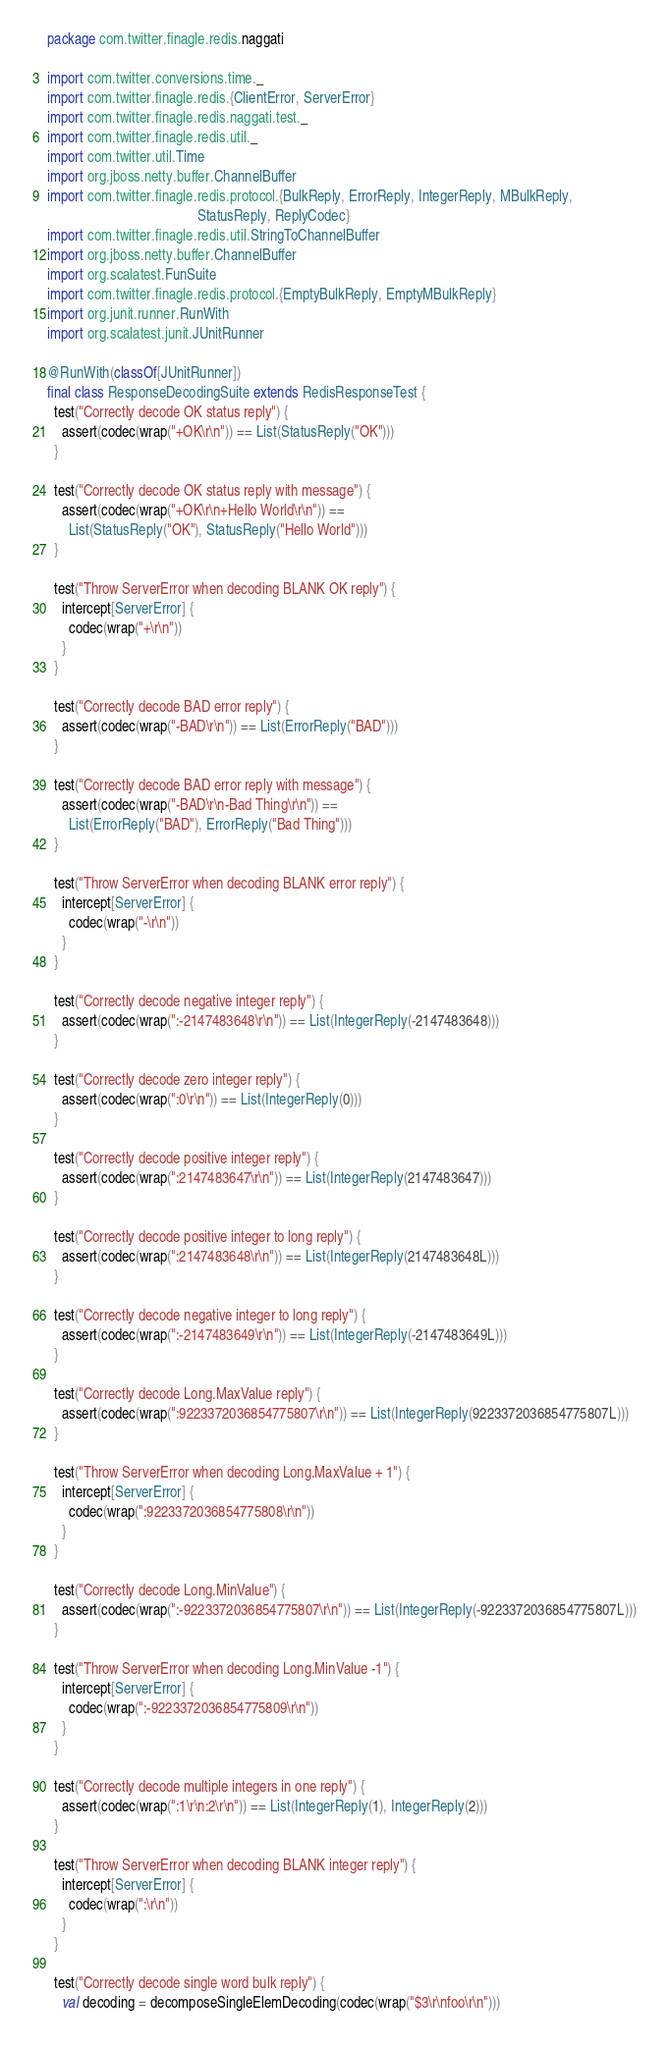<code> <loc_0><loc_0><loc_500><loc_500><_Scala_>package com.twitter.finagle.redis.naggati

import com.twitter.conversions.time._
import com.twitter.finagle.redis.{ClientError, ServerError}
import com.twitter.finagle.redis.naggati.test._
import com.twitter.finagle.redis.util._
import com.twitter.util.Time
import org.jboss.netty.buffer.ChannelBuffer
import com.twitter.finagle.redis.protocol.{BulkReply, ErrorReply, IntegerReply, MBulkReply,
                                          StatusReply, ReplyCodec}
import com.twitter.finagle.redis.util.StringToChannelBuffer
import org.jboss.netty.buffer.ChannelBuffer
import org.scalatest.FunSuite
import com.twitter.finagle.redis.protocol.{EmptyBulkReply, EmptyMBulkReply}
import org.junit.runner.RunWith
import org.scalatest.junit.JUnitRunner

@RunWith(classOf[JUnitRunner])
final class ResponseDecodingSuite extends RedisResponseTest {
  test("Correctly decode OK status reply") {
    assert(codec(wrap("+OK\r\n")) == List(StatusReply("OK")))
  }

  test("Correctly decode OK status reply with message") {
    assert(codec(wrap("+OK\r\n+Hello World\r\n")) ==
      List(StatusReply("OK"), StatusReply("Hello World")))
  }

  test("Throw ServerError when decoding BLANK OK reply") {
    intercept[ServerError] {
      codec(wrap("+\r\n"))
    }
  }

  test("Correctly decode BAD error reply") {
    assert(codec(wrap("-BAD\r\n")) == List(ErrorReply("BAD")))
  }

  test("Correctly decode BAD error reply with message") {
    assert(codec(wrap("-BAD\r\n-Bad Thing\r\n")) ==
      List(ErrorReply("BAD"), ErrorReply("Bad Thing")))
  }

  test("Throw ServerError when decoding BLANK error reply") {
    intercept[ServerError] {
      codec(wrap("-\r\n"))
    }
  }

  test("Correctly decode negative integer reply") {
    assert(codec(wrap(":-2147483648\r\n")) == List(IntegerReply(-2147483648)))
  }

  test("Correctly decode zero integer reply") {
    assert(codec(wrap(":0\r\n")) == List(IntegerReply(0)))
  }

  test("Correctly decode positive integer reply") {
    assert(codec(wrap(":2147483647\r\n")) == List(IntegerReply(2147483647)))
  }

  test("Correctly decode positive integer to long reply") {
    assert(codec(wrap(":2147483648\r\n")) == List(IntegerReply(2147483648L)))
  }

  test("Correctly decode negative integer to long reply") {
    assert(codec(wrap(":-2147483649\r\n")) == List(IntegerReply(-2147483649L)))
  }

  test("Correctly decode Long.MaxValue reply") {
    assert(codec(wrap(":9223372036854775807\r\n")) == List(IntegerReply(9223372036854775807L)))
  }

  test("Throw ServerError when decoding Long.MaxValue + 1") {
    intercept[ServerError] {
      codec(wrap(":9223372036854775808\r\n"))
    }
  }

  test("Correctly decode Long.MinValue") {
    assert(codec(wrap(":-9223372036854775807\r\n")) == List(IntegerReply(-9223372036854775807L)))
  }

  test("Throw ServerError when decoding Long.MinValue -1") {
    intercept[ServerError] {
      codec(wrap(":-9223372036854775809\r\n"))
    }
  }

  test("Correctly decode multiple integers in one reply") {
    assert(codec(wrap(":1\r\n:2\r\n")) == List(IntegerReply(1), IntegerReply(2)))
  }

  test("Throw ServerError when decoding BLANK integer reply") {
    intercept[ServerError] {
      codec(wrap(":\r\n"))
    }
  }

  test("Correctly decode single word bulk reply") {
    val decoding = decomposeSingleElemDecoding(codec(wrap("$3\r\nfoo\r\n")))</code> 